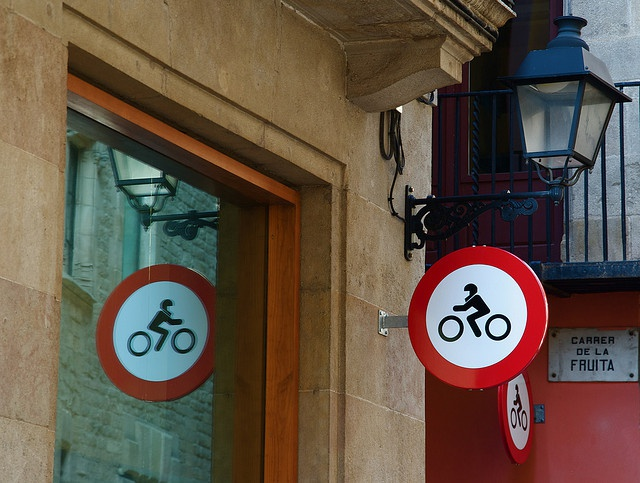Describe the objects in this image and their specific colors. I can see a stop sign in olive, brown, and lightblue tones in this image. 